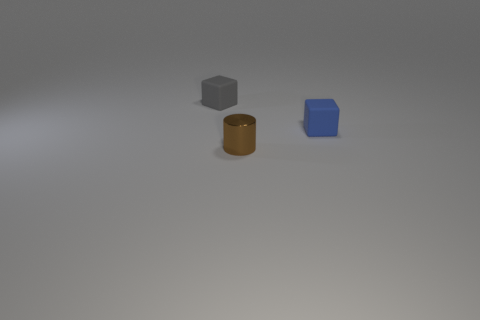Add 2 shiny things. How many objects exist? 5 Subtract all blocks. How many objects are left? 1 Subtract all tiny metal objects. Subtract all small yellow shiny balls. How many objects are left? 2 Add 3 brown objects. How many brown objects are left? 4 Add 3 tiny things. How many tiny things exist? 6 Subtract 0 gray balls. How many objects are left? 3 